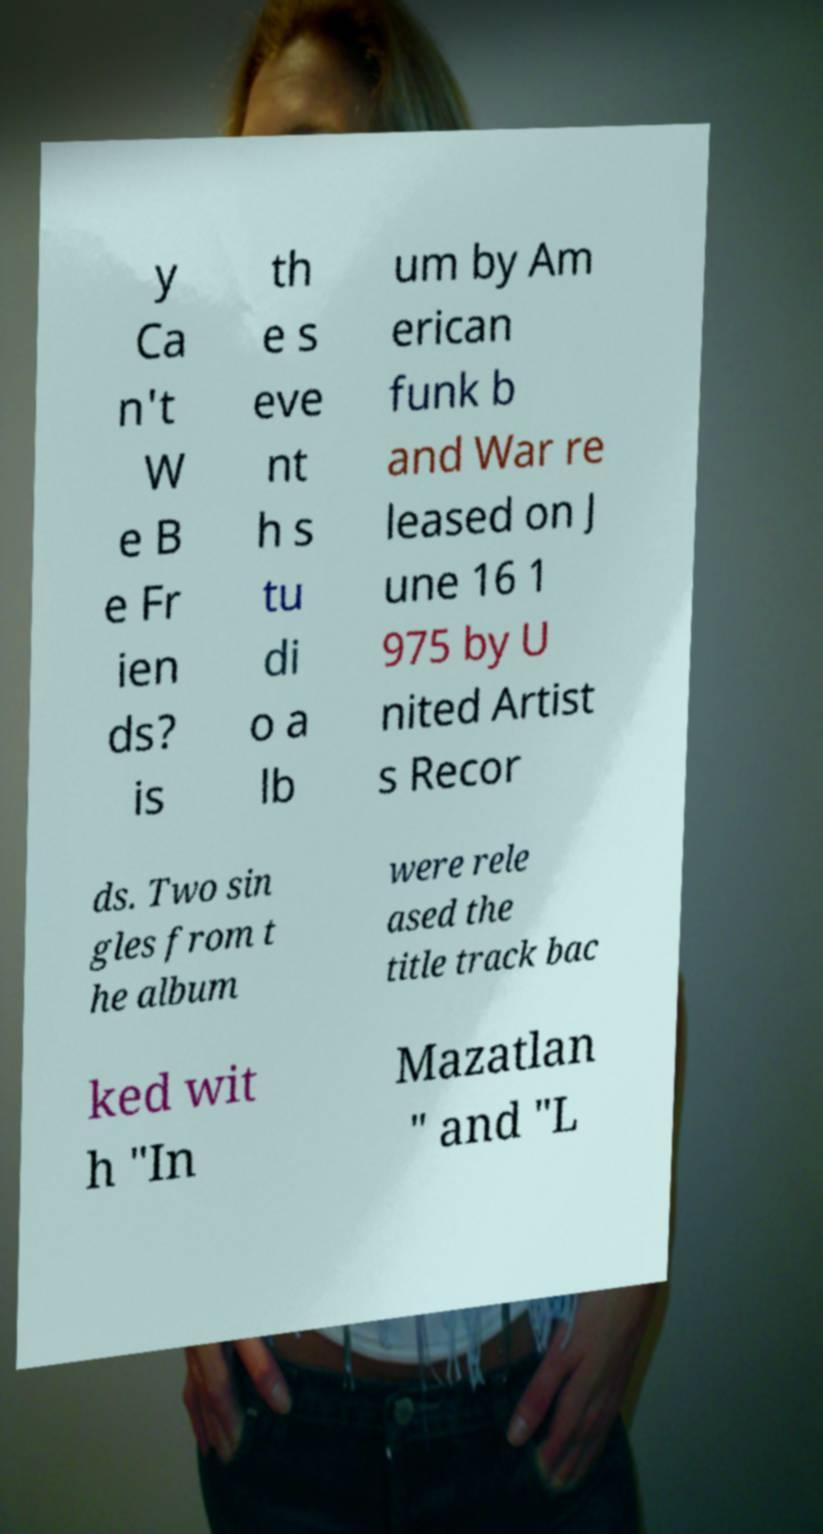Please read and relay the text visible in this image. What does it say? y Ca n't W e B e Fr ien ds? is th e s eve nt h s tu di o a lb um by Am erican funk b and War re leased on J une 16 1 975 by U nited Artist s Recor ds. Two sin gles from t he album were rele ased the title track bac ked wit h "In Mazatlan " and "L 